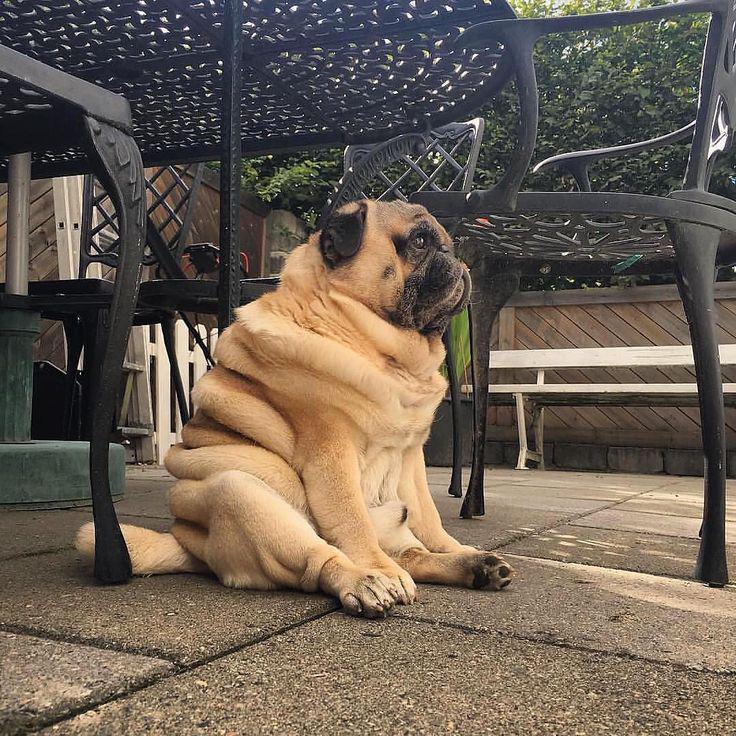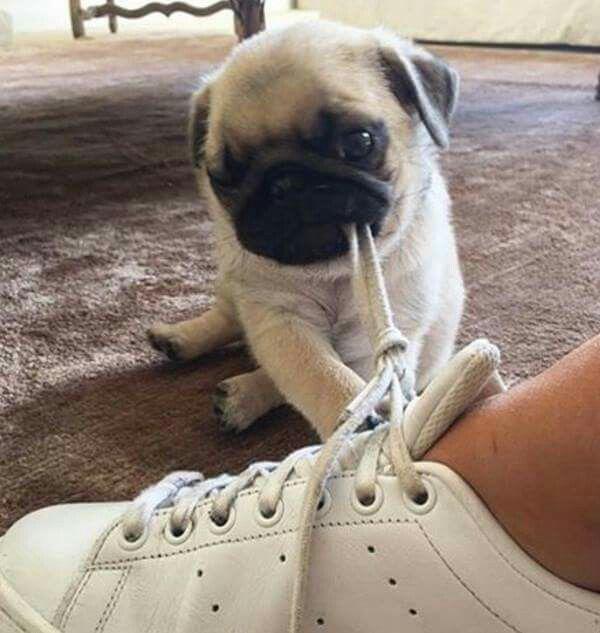The first image is the image on the left, the second image is the image on the right. For the images shown, is this caption "The left image contains no more than one dog." true? Answer yes or no. Yes. The first image is the image on the left, the second image is the image on the right. Examine the images to the left and right. Is the description "One image shows a pug sitting, with its hind legs extended, on cement next to something made of metal." accurate? Answer yes or no. Yes. 